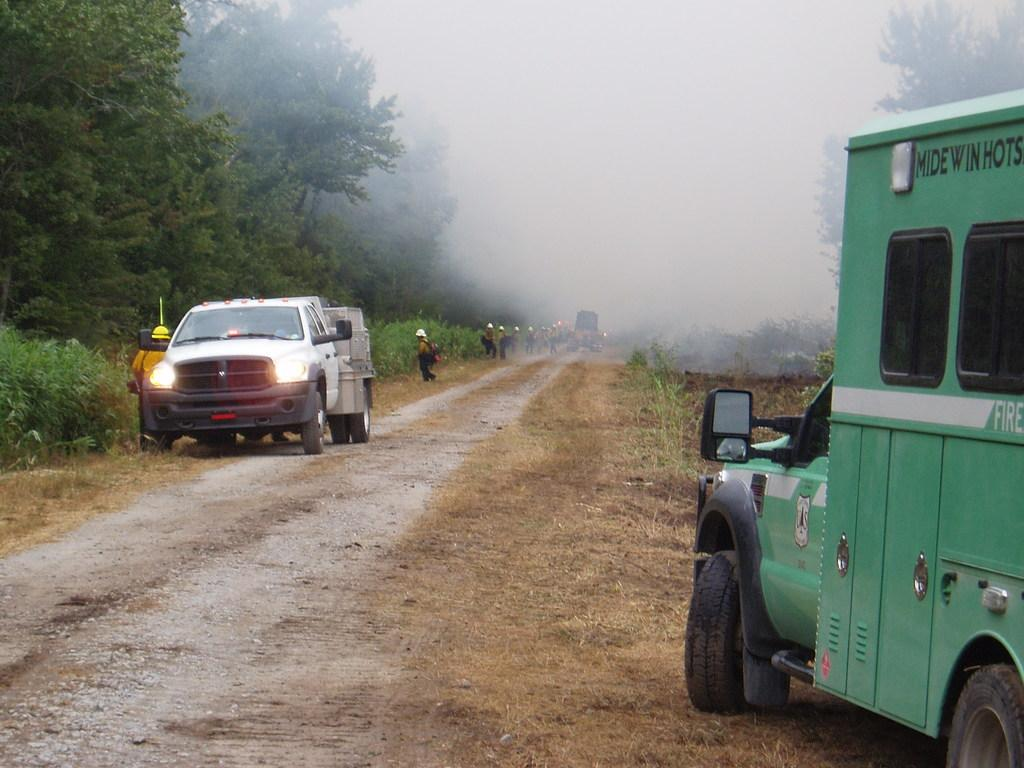What types of objects can be seen in the image? There are vehicles in the image. Are there any living beings present in the image? Yes, there are people in the image. What elements of nature can be observed in the image? There are plants and trees in the image. Can you see any cows grazing in the image? No, there are no cows present in the image. Is there any quicksand visible in the image? No, there is no quicksand present in the image. 